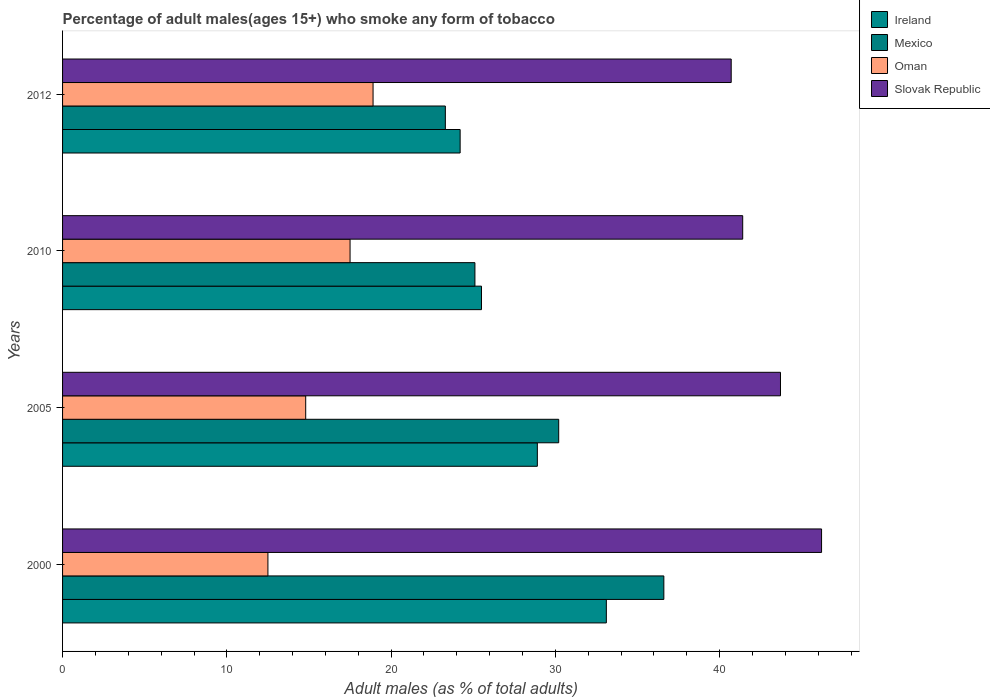How many different coloured bars are there?
Your answer should be compact. 4. Are the number of bars on each tick of the Y-axis equal?
Ensure brevity in your answer.  Yes. How many bars are there on the 3rd tick from the bottom?
Provide a succinct answer. 4. What is the label of the 4th group of bars from the top?
Keep it short and to the point. 2000. What is the percentage of adult males who smoke in Ireland in 2005?
Ensure brevity in your answer.  28.9. Across all years, what is the maximum percentage of adult males who smoke in Mexico?
Your answer should be compact. 36.6. Across all years, what is the minimum percentage of adult males who smoke in Ireland?
Make the answer very short. 24.2. In which year was the percentage of adult males who smoke in Oman maximum?
Your answer should be very brief. 2012. What is the total percentage of adult males who smoke in Mexico in the graph?
Your answer should be very brief. 115.2. What is the difference between the percentage of adult males who smoke in Ireland in 2005 and the percentage of adult males who smoke in Slovak Republic in 2012?
Your response must be concise. -11.8. What is the average percentage of adult males who smoke in Ireland per year?
Give a very brief answer. 27.93. In the year 2010, what is the difference between the percentage of adult males who smoke in Slovak Republic and percentage of adult males who smoke in Oman?
Give a very brief answer. 23.9. In how many years, is the percentage of adult males who smoke in Oman greater than 28 %?
Your response must be concise. 0. What is the ratio of the percentage of adult males who smoke in Slovak Republic in 2005 to that in 2010?
Give a very brief answer. 1.06. Is the percentage of adult males who smoke in Mexico in 2005 less than that in 2010?
Give a very brief answer. No. Is the difference between the percentage of adult males who smoke in Slovak Republic in 2000 and 2010 greater than the difference between the percentage of adult males who smoke in Oman in 2000 and 2010?
Your answer should be compact. Yes. What is the difference between the highest and the second highest percentage of adult males who smoke in Mexico?
Provide a short and direct response. 6.4. What is the difference between the highest and the lowest percentage of adult males who smoke in Oman?
Offer a very short reply. 6.4. In how many years, is the percentage of adult males who smoke in Oman greater than the average percentage of adult males who smoke in Oman taken over all years?
Make the answer very short. 2. Is it the case that in every year, the sum of the percentage of adult males who smoke in Mexico and percentage of adult males who smoke in Ireland is greater than the sum of percentage of adult males who smoke in Slovak Republic and percentage of adult males who smoke in Oman?
Offer a terse response. Yes. What does the 4th bar from the top in 2000 represents?
Keep it short and to the point. Ireland. What does the 2nd bar from the bottom in 2000 represents?
Offer a terse response. Mexico. How many bars are there?
Make the answer very short. 16. What is the difference between two consecutive major ticks on the X-axis?
Your answer should be compact. 10. Where does the legend appear in the graph?
Offer a very short reply. Top right. What is the title of the graph?
Keep it short and to the point. Percentage of adult males(ages 15+) who smoke any form of tobacco. What is the label or title of the X-axis?
Provide a short and direct response. Adult males (as % of total adults). What is the label or title of the Y-axis?
Offer a very short reply. Years. What is the Adult males (as % of total adults) of Ireland in 2000?
Make the answer very short. 33.1. What is the Adult males (as % of total adults) in Mexico in 2000?
Your response must be concise. 36.6. What is the Adult males (as % of total adults) of Oman in 2000?
Keep it short and to the point. 12.5. What is the Adult males (as % of total adults) in Slovak Republic in 2000?
Your answer should be very brief. 46.2. What is the Adult males (as % of total adults) in Ireland in 2005?
Your answer should be compact. 28.9. What is the Adult males (as % of total adults) of Mexico in 2005?
Offer a terse response. 30.2. What is the Adult males (as % of total adults) in Oman in 2005?
Keep it short and to the point. 14.8. What is the Adult males (as % of total adults) of Slovak Republic in 2005?
Your answer should be very brief. 43.7. What is the Adult males (as % of total adults) in Ireland in 2010?
Your answer should be compact. 25.5. What is the Adult males (as % of total adults) in Mexico in 2010?
Offer a terse response. 25.1. What is the Adult males (as % of total adults) of Oman in 2010?
Provide a short and direct response. 17.5. What is the Adult males (as % of total adults) of Slovak Republic in 2010?
Offer a very short reply. 41.4. What is the Adult males (as % of total adults) in Ireland in 2012?
Provide a succinct answer. 24.2. What is the Adult males (as % of total adults) of Mexico in 2012?
Give a very brief answer. 23.3. What is the Adult males (as % of total adults) in Oman in 2012?
Your answer should be compact. 18.9. What is the Adult males (as % of total adults) of Slovak Republic in 2012?
Keep it short and to the point. 40.7. Across all years, what is the maximum Adult males (as % of total adults) of Ireland?
Give a very brief answer. 33.1. Across all years, what is the maximum Adult males (as % of total adults) in Mexico?
Provide a succinct answer. 36.6. Across all years, what is the maximum Adult males (as % of total adults) of Slovak Republic?
Make the answer very short. 46.2. Across all years, what is the minimum Adult males (as % of total adults) in Ireland?
Keep it short and to the point. 24.2. Across all years, what is the minimum Adult males (as % of total adults) in Mexico?
Ensure brevity in your answer.  23.3. Across all years, what is the minimum Adult males (as % of total adults) of Slovak Republic?
Ensure brevity in your answer.  40.7. What is the total Adult males (as % of total adults) of Ireland in the graph?
Give a very brief answer. 111.7. What is the total Adult males (as % of total adults) in Mexico in the graph?
Make the answer very short. 115.2. What is the total Adult males (as % of total adults) of Oman in the graph?
Keep it short and to the point. 63.7. What is the total Adult males (as % of total adults) in Slovak Republic in the graph?
Ensure brevity in your answer.  172. What is the difference between the Adult males (as % of total adults) in Oman in 2000 and that in 2005?
Your response must be concise. -2.3. What is the difference between the Adult males (as % of total adults) of Ireland in 2000 and that in 2010?
Provide a short and direct response. 7.6. What is the difference between the Adult males (as % of total adults) of Ireland in 2000 and that in 2012?
Offer a terse response. 8.9. What is the difference between the Adult males (as % of total adults) in Ireland in 2005 and that in 2010?
Your answer should be very brief. 3.4. What is the difference between the Adult males (as % of total adults) in Mexico in 2005 and that in 2010?
Provide a succinct answer. 5.1. What is the difference between the Adult males (as % of total adults) of Mexico in 2005 and that in 2012?
Ensure brevity in your answer.  6.9. What is the difference between the Adult males (as % of total adults) of Ireland in 2010 and that in 2012?
Your answer should be very brief. 1.3. What is the difference between the Adult males (as % of total adults) of Mexico in 2010 and that in 2012?
Your answer should be compact. 1.8. What is the difference between the Adult males (as % of total adults) of Slovak Republic in 2010 and that in 2012?
Offer a terse response. 0.7. What is the difference between the Adult males (as % of total adults) of Mexico in 2000 and the Adult males (as % of total adults) of Oman in 2005?
Provide a short and direct response. 21.8. What is the difference between the Adult males (as % of total adults) of Oman in 2000 and the Adult males (as % of total adults) of Slovak Republic in 2005?
Your answer should be very brief. -31.2. What is the difference between the Adult males (as % of total adults) of Ireland in 2000 and the Adult males (as % of total adults) of Slovak Republic in 2010?
Give a very brief answer. -8.3. What is the difference between the Adult males (as % of total adults) in Mexico in 2000 and the Adult males (as % of total adults) in Oman in 2010?
Your answer should be compact. 19.1. What is the difference between the Adult males (as % of total adults) in Mexico in 2000 and the Adult males (as % of total adults) in Slovak Republic in 2010?
Offer a very short reply. -4.8. What is the difference between the Adult males (as % of total adults) of Oman in 2000 and the Adult males (as % of total adults) of Slovak Republic in 2010?
Your answer should be very brief. -28.9. What is the difference between the Adult males (as % of total adults) in Ireland in 2000 and the Adult males (as % of total adults) in Mexico in 2012?
Your answer should be compact. 9.8. What is the difference between the Adult males (as % of total adults) of Ireland in 2000 and the Adult males (as % of total adults) of Slovak Republic in 2012?
Provide a succinct answer. -7.6. What is the difference between the Adult males (as % of total adults) of Oman in 2000 and the Adult males (as % of total adults) of Slovak Republic in 2012?
Your answer should be very brief. -28.2. What is the difference between the Adult males (as % of total adults) of Ireland in 2005 and the Adult males (as % of total adults) of Oman in 2010?
Make the answer very short. 11.4. What is the difference between the Adult males (as % of total adults) in Mexico in 2005 and the Adult males (as % of total adults) in Slovak Republic in 2010?
Provide a succinct answer. -11.2. What is the difference between the Adult males (as % of total adults) in Oman in 2005 and the Adult males (as % of total adults) in Slovak Republic in 2010?
Your response must be concise. -26.6. What is the difference between the Adult males (as % of total adults) in Ireland in 2005 and the Adult males (as % of total adults) in Mexico in 2012?
Your answer should be compact. 5.6. What is the difference between the Adult males (as % of total adults) in Ireland in 2005 and the Adult males (as % of total adults) in Slovak Republic in 2012?
Offer a terse response. -11.8. What is the difference between the Adult males (as % of total adults) of Mexico in 2005 and the Adult males (as % of total adults) of Slovak Republic in 2012?
Keep it short and to the point. -10.5. What is the difference between the Adult males (as % of total adults) of Oman in 2005 and the Adult males (as % of total adults) of Slovak Republic in 2012?
Your answer should be very brief. -25.9. What is the difference between the Adult males (as % of total adults) in Ireland in 2010 and the Adult males (as % of total adults) in Mexico in 2012?
Your response must be concise. 2.2. What is the difference between the Adult males (as % of total adults) of Ireland in 2010 and the Adult males (as % of total adults) of Slovak Republic in 2012?
Keep it short and to the point. -15.2. What is the difference between the Adult males (as % of total adults) in Mexico in 2010 and the Adult males (as % of total adults) in Slovak Republic in 2012?
Your response must be concise. -15.6. What is the difference between the Adult males (as % of total adults) in Oman in 2010 and the Adult males (as % of total adults) in Slovak Republic in 2012?
Your answer should be compact. -23.2. What is the average Adult males (as % of total adults) of Ireland per year?
Provide a short and direct response. 27.93. What is the average Adult males (as % of total adults) of Mexico per year?
Keep it short and to the point. 28.8. What is the average Adult males (as % of total adults) of Oman per year?
Offer a very short reply. 15.93. What is the average Adult males (as % of total adults) in Slovak Republic per year?
Offer a very short reply. 43. In the year 2000, what is the difference between the Adult males (as % of total adults) in Ireland and Adult males (as % of total adults) in Mexico?
Give a very brief answer. -3.5. In the year 2000, what is the difference between the Adult males (as % of total adults) of Ireland and Adult males (as % of total adults) of Oman?
Your answer should be very brief. 20.6. In the year 2000, what is the difference between the Adult males (as % of total adults) of Mexico and Adult males (as % of total adults) of Oman?
Ensure brevity in your answer.  24.1. In the year 2000, what is the difference between the Adult males (as % of total adults) of Mexico and Adult males (as % of total adults) of Slovak Republic?
Make the answer very short. -9.6. In the year 2000, what is the difference between the Adult males (as % of total adults) of Oman and Adult males (as % of total adults) of Slovak Republic?
Offer a very short reply. -33.7. In the year 2005, what is the difference between the Adult males (as % of total adults) in Ireland and Adult males (as % of total adults) in Slovak Republic?
Make the answer very short. -14.8. In the year 2005, what is the difference between the Adult males (as % of total adults) in Mexico and Adult males (as % of total adults) in Slovak Republic?
Provide a short and direct response. -13.5. In the year 2005, what is the difference between the Adult males (as % of total adults) in Oman and Adult males (as % of total adults) in Slovak Republic?
Provide a short and direct response. -28.9. In the year 2010, what is the difference between the Adult males (as % of total adults) of Ireland and Adult males (as % of total adults) of Oman?
Offer a very short reply. 8. In the year 2010, what is the difference between the Adult males (as % of total adults) of Ireland and Adult males (as % of total adults) of Slovak Republic?
Offer a very short reply. -15.9. In the year 2010, what is the difference between the Adult males (as % of total adults) of Mexico and Adult males (as % of total adults) of Oman?
Provide a short and direct response. 7.6. In the year 2010, what is the difference between the Adult males (as % of total adults) in Mexico and Adult males (as % of total adults) in Slovak Republic?
Keep it short and to the point. -16.3. In the year 2010, what is the difference between the Adult males (as % of total adults) of Oman and Adult males (as % of total adults) of Slovak Republic?
Provide a succinct answer. -23.9. In the year 2012, what is the difference between the Adult males (as % of total adults) in Ireland and Adult males (as % of total adults) in Oman?
Provide a short and direct response. 5.3. In the year 2012, what is the difference between the Adult males (as % of total adults) in Ireland and Adult males (as % of total adults) in Slovak Republic?
Make the answer very short. -16.5. In the year 2012, what is the difference between the Adult males (as % of total adults) in Mexico and Adult males (as % of total adults) in Slovak Republic?
Your response must be concise. -17.4. In the year 2012, what is the difference between the Adult males (as % of total adults) of Oman and Adult males (as % of total adults) of Slovak Republic?
Offer a very short reply. -21.8. What is the ratio of the Adult males (as % of total adults) in Ireland in 2000 to that in 2005?
Your response must be concise. 1.15. What is the ratio of the Adult males (as % of total adults) of Mexico in 2000 to that in 2005?
Your response must be concise. 1.21. What is the ratio of the Adult males (as % of total adults) of Oman in 2000 to that in 2005?
Offer a terse response. 0.84. What is the ratio of the Adult males (as % of total adults) in Slovak Republic in 2000 to that in 2005?
Ensure brevity in your answer.  1.06. What is the ratio of the Adult males (as % of total adults) in Ireland in 2000 to that in 2010?
Keep it short and to the point. 1.3. What is the ratio of the Adult males (as % of total adults) in Mexico in 2000 to that in 2010?
Provide a succinct answer. 1.46. What is the ratio of the Adult males (as % of total adults) of Slovak Republic in 2000 to that in 2010?
Make the answer very short. 1.12. What is the ratio of the Adult males (as % of total adults) of Ireland in 2000 to that in 2012?
Offer a terse response. 1.37. What is the ratio of the Adult males (as % of total adults) in Mexico in 2000 to that in 2012?
Offer a very short reply. 1.57. What is the ratio of the Adult males (as % of total adults) in Oman in 2000 to that in 2012?
Offer a very short reply. 0.66. What is the ratio of the Adult males (as % of total adults) in Slovak Republic in 2000 to that in 2012?
Your answer should be very brief. 1.14. What is the ratio of the Adult males (as % of total adults) in Ireland in 2005 to that in 2010?
Your answer should be very brief. 1.13. What is the ratio of the Adult males (as % of total adults) of Mexico in 2005 to that in 2010?
Make the answer very short. 1.2. What is the ratio of the Adult males (as % of total adults) in Oman in 2005 to that in 2010?
Your response must be concise. 0.85. What is the ratio of the Adult males (as % of total adults) of Slovak Republic in 2005 to that in 2010?
Offer a terse response. 1.06. What is the ratio of the Adult males (as % of total adults) in Ireland in 2005 to that in 2012?
Provide a succinct answer. 1.19. What is the ratio of the Adult males (as % of total adults) of Mexico in 2005 to that in 2012?
Offer a very short reply. 1.3. What is the ratio of the Adult males (as % of total adults) in Oman in 2005 to that in 2012?
Your answer should be very brief. 0.78. What is the ratio of the Adult males (as % of total adults) of Slovak Republic in 2005 to that in 2012?
Provide a succinct answer. 1.07. What is the ratio of the Adult males (as % of total adults) in Ireland in 2010 to that in 2012?
Give a very brief answer. 1.05. What is the ratio of the Adult males (as % of total adults) in Mexico in 2010 to that in 2012?
Ensure brevity in your answer.  1.08. What is the ratio of the Adult males (as % of total adults) in Oman in 2010 to that in 2012?
Give a very brief answer. 0.93. What is the ratio of the Adult males (as % of total adults) in Slovak Republic in 2010 to that in 2012?
Offer a terse response. 1.02. What is the difference between the highest and the second highest Adult males (as % of total adults) in Ireland?
Keep it short and to the point. 4.2. What is the difference between the highest and the second highest Adult males (as % of total adults) in Mexico?
Offer a very short reply. 6.4. What is the difference between the highest and the second highest Adult males (as % of total adults) in Oman?
Ensure brevity in your answer.  1.4. What is the difference between the highest and the second highest Adult males (as % of total adults) in Slovak Republic?
Your response must be concise. 2.5. What is the difference between the highest and the lowest Adult males (as % of total adults) of Mexico?
Make the answer very short. 13.3. What is the difference between the highest and the lowest Adult males (as % of total adults) of Slovak Republic?
Ensure brevity in your answer.  5.5. 